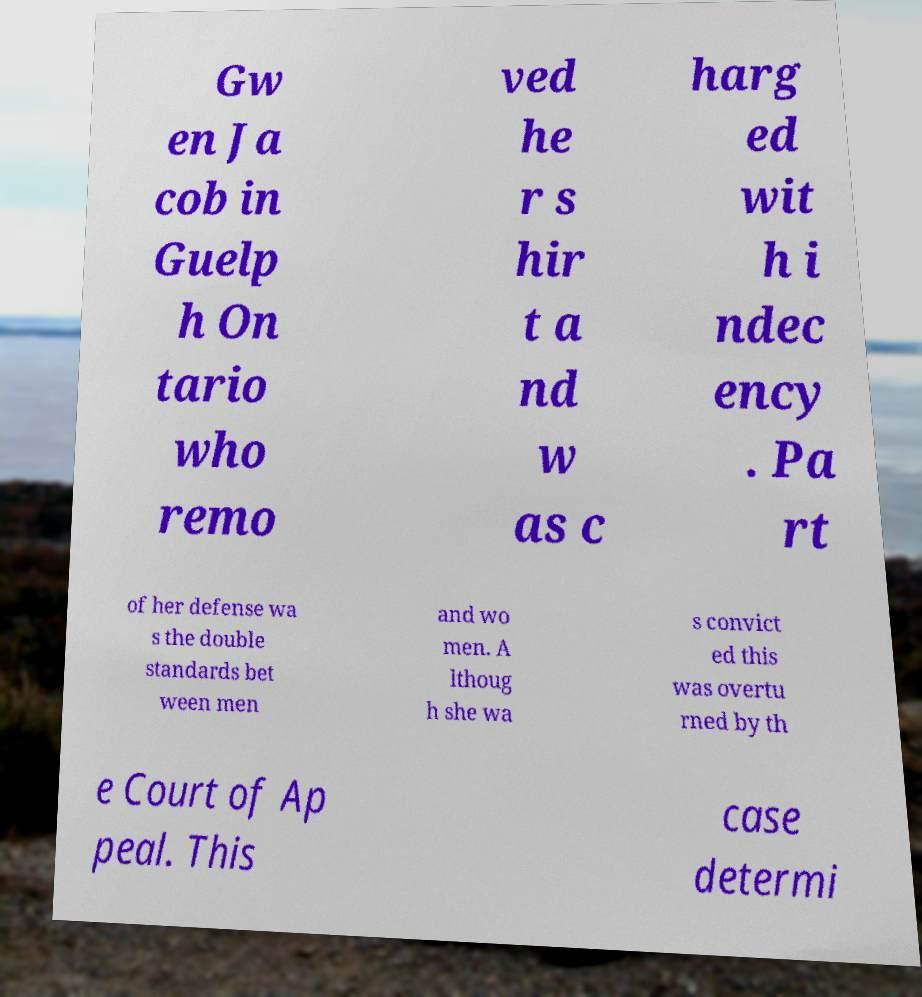I need the written content from this picture converted into text. Can you do that? Gw en Ja cob in Guelp h On tario who remo ved he r s hir t a nd w as c harg ed wit h i ndec ency . Pa rt of her defense wa s the double standards bet ween men and wo men. A lthoug h she wa s convict ed this was overtu rned by th e Court of Ap peal. This case determi 